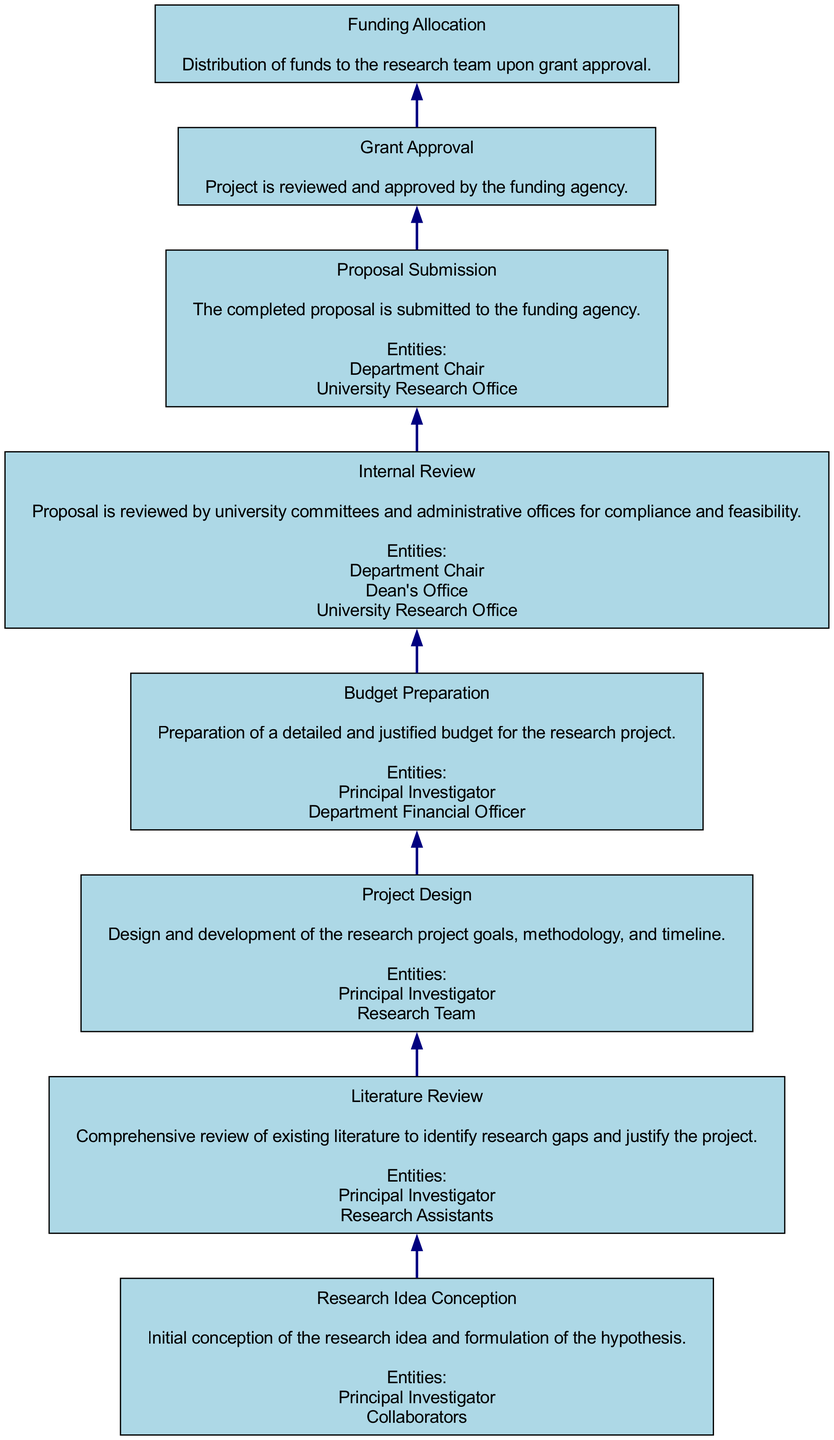What is the final step in the grant proposal submission process? The flow chart indicates that the final step is "Funding Allocation," which occurs after the grant is approved. This reflects the endpoint of the process as shown in the diagram.
Answer: Funding Allocation How many primary entities are involved in the "Proposal Submission" step? In the "Proposal Submission" step, the chart identifies two entities: "Department Chair" and "University Research Office." By counting these entities, we see there are two involved in this step.
Answer: 2 What step follows "Budget Preparation"? According to the flow chart, "Proposal Submission" follows "Budget Preparation" as it is directly connected in the progression of the diagram. This is traced by moving one level up from "Budget Preparation."
Answer: Proposal Submission Which step involves conducting a literature review? The diagram explicitly states that the "Literature Review" is a separate step, indicating that it is focused on reviewing existing research literature to identify gaps. It is not combined with any other steps.
Answer: Literature Review What is the main function of "Internal Review"? The "Internal Review" step is designed for proposals to be reviewed by university committees for compliance and feasibility, according to the description provided in the diagram.
Answer: Compliance and feasibility How many steps are there in total from "Research Idea Conception" to "Funding Allocation"? To find the total number of steps, we count each node from "Research Idea Conception" to "Funding Allocation." Starting from the bottom (Research Idea Conception) to the top (Funding Allocation), there are 8 steps in total, which includes all nodes in the flowchart.
Answer: 8 Who are the entities involved in the "Project Design"? The "Project Design" step includes entities listed as "Principal Investigator" and "Research Team." By directly reading from the relevant node in the diagram, we identify these two key participants.
Answer: Principal Investigator, Research Team 